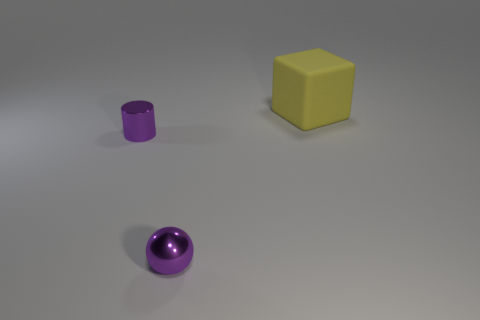Are there the same number of yellow rubber blocks that are on the right side of the yellow object and big purple shiny objects?
Make the answer very short. Yes. Does the big thing have the same color as the metal sphere?
Make the answer very short. No. What is the size of the object that is both on the right side of the small purple metallic cylinder and to the left of the matte block?
Give a very brief answer. Small. There is a cylinder that is made of the same material as the small purple ball; what color is it?
Provide a succinct answer. Purple. What number of other things are the same material as the yellow object?
Your answer should be compact. 0. Are there an equal number of tiny purple metallic cylinders that are on the right side of the metal sphere and tiny purple metal cylinders on the left side of the tiny purple shiny cylinder?
Your answer should be very brief. Yes. Is the shape of the yellow rubber object the same as the metallic thing in front of the tiny purple cylinder?
Make the answer very short. No. What material is the cylinder that is the same color as the sphere?
Keep it short and to the point. Metal. Is there any other thing that is the same shape as the large yellow rubber object?
Ensure brevity in your answer.  No. Do the purple cylinder and the small purple object to the right of the small purple metallic cylinder have the same material?
Provide a succinct answer. Yes. 